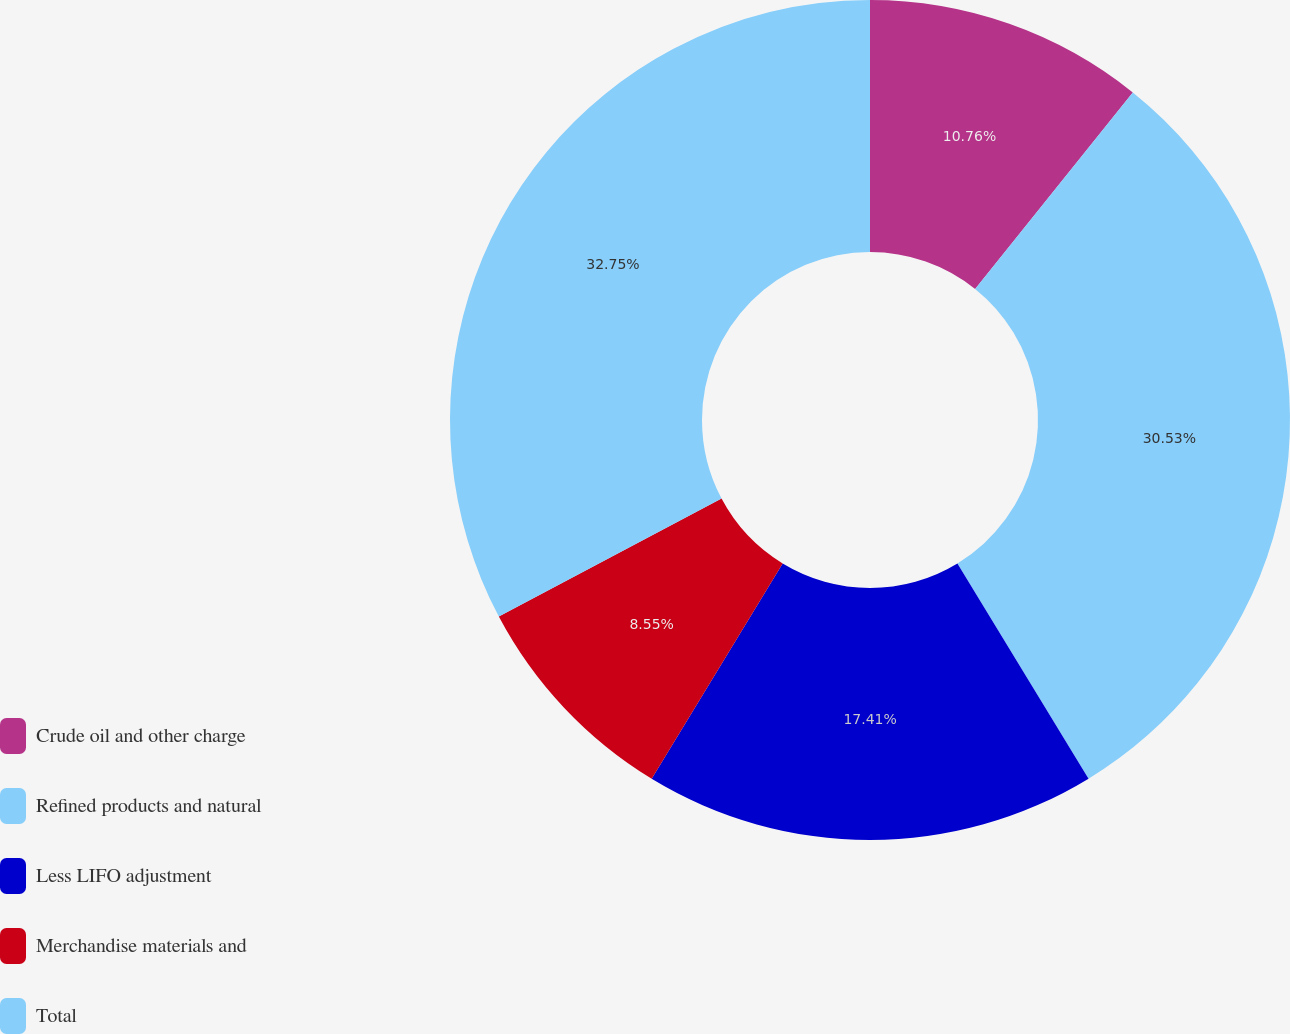Convert chart to OTSL. <chart><loc_0><loc_0><loc_500><loc_500><pie_chart><fcel>Crude oil and other charge<fcel>Refined products and natural<fcel>Less LIFO adjustment<fcel>Merchandise materials and<fcel>Total<nl><fcel>10.76%<fcel>30.53%<fcel>17.41%<fcel>8.55%<fcel>32.75%<nl></chart> 